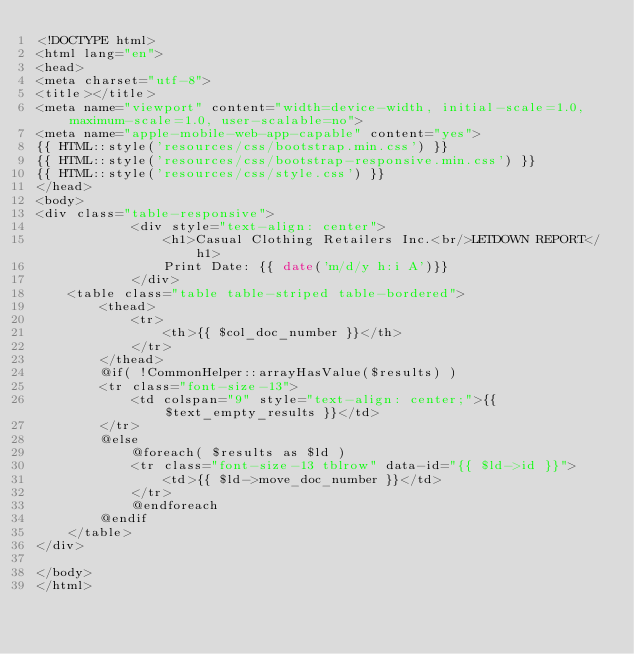<code> <loc_0><loc_0><loc_500><loc_500><_PHP_><!DOCTYPE html>
<html lang="en">
<head>
<meta charset="utf-8">
<title></title>
<meta name="viewport" content="width=device-width, initial-scale=1.0, maximum-scale=1.0, user-scalable=no">
<meta name="apple-mobile-web-app-capable" content="yes">
{{ HTML::style('resources/css/bootstrap.min.css') }}
{{ HTML::style('resources/css/bootstrap-responsive.min.css') }}
{{ HTML::style('resources/css/style.css') }}
</head>
<body>
<div class="table-responsive">
			<div style="text-align: center">
				<h1>Casual Clothing Retailers Inc.<br/>LETDOWN REPORT</h1>
				Print Date: {{ date('m/d/y h:i A')}}
			</div>
	<table class="table table-striped table-bordered">
		<thead>
			<tr>
				<th>{{ $col_doc_number }}</th>
			</tr>
		</thead>
		@if( !CommonHelper::arrayHasValue($results) )
		<tr class="font-size-13">
			<td colspan="9" style="text-align: center;">{{ $text_empty_results }}</td>
		</tr>
		@else
			@foreach( $results as $ld )
			<tr class="font-size-13 tblrow" data-id="{{ $ld->id }}">
				<td>{{ $ld->move_doc_number }}</td>
			</tr>
			@endforeach
		@endif
	</table>
</div>

</body>
</html></code> 